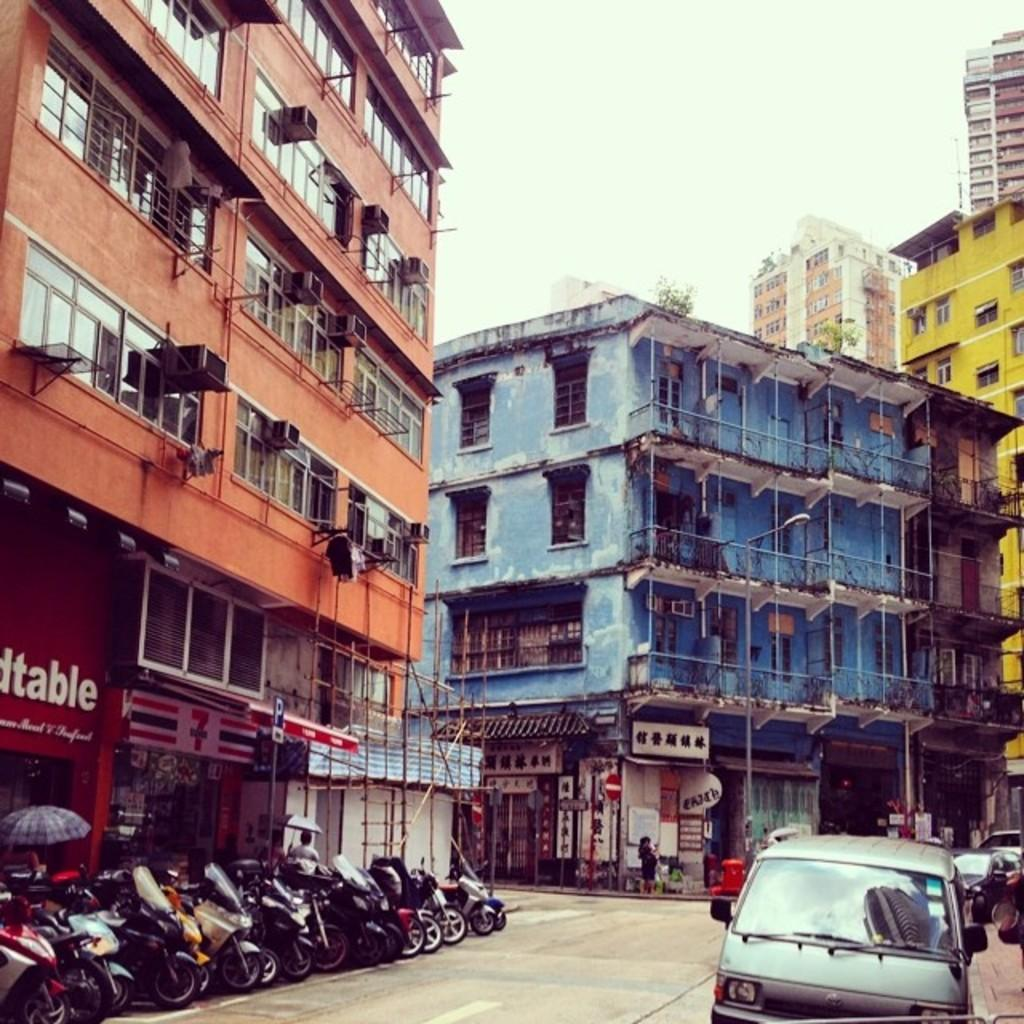What can be seen in the center of the image? A: There are cars on the road in the center of the image. What is located on the left side of the image? There are lampposts in a row on the left side of the image. What is visible in the background of the image? There are buildings, trees, and the sky in the background of the image. What type of soup is being served in the image? There is no soup present in the image. What is the source of fear in the image? There is no fear depicted in the image; it shows cars, lampposts, buildings, trees, and the sky. 